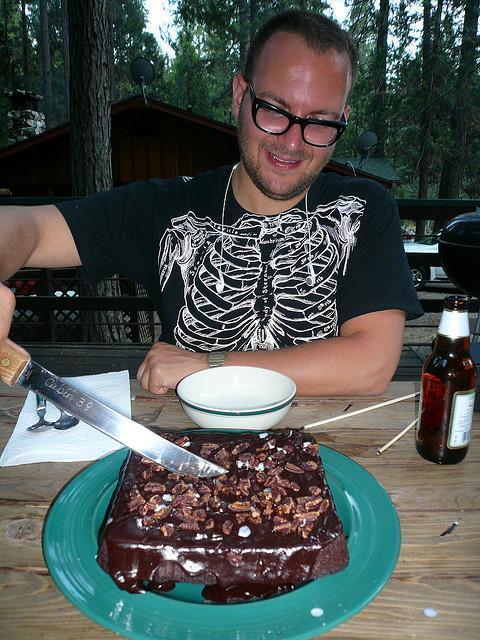Is the caption "The person is touching the dining table." a true representation of the image?
Answer yes or no. Yes. Does the description: "The cake is at the left side of the person." accurately reflect the image?
Answer yes or no. No. Evaluate: Does the caption "The cake is in front of the bowl." match the image?
Answer yes or no. Yes. 